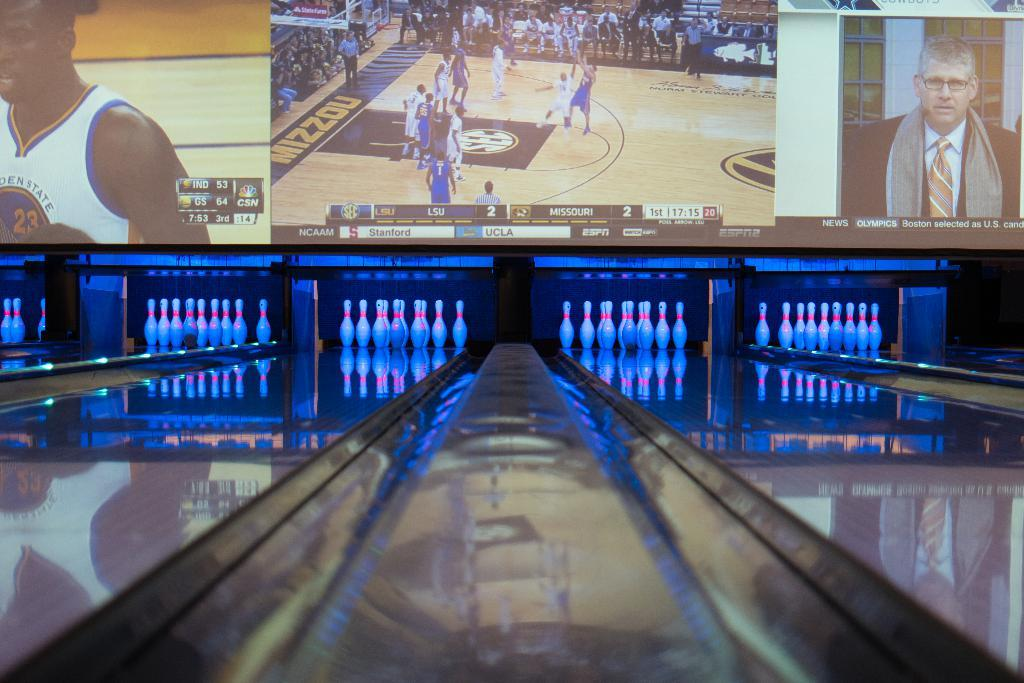What type of game is being played in the image? There is a ten pin bowling game in the image. What can be seen in the background of the image? There is a screen in the background of the image. What is displayed on the screen? Pictures are visible on the screen. What type of wine is being served at the bowling alley in the image? There is no wine or indication of a bowling alley in the image; it only shows a ten pin bowling game and a screen with pictures. 